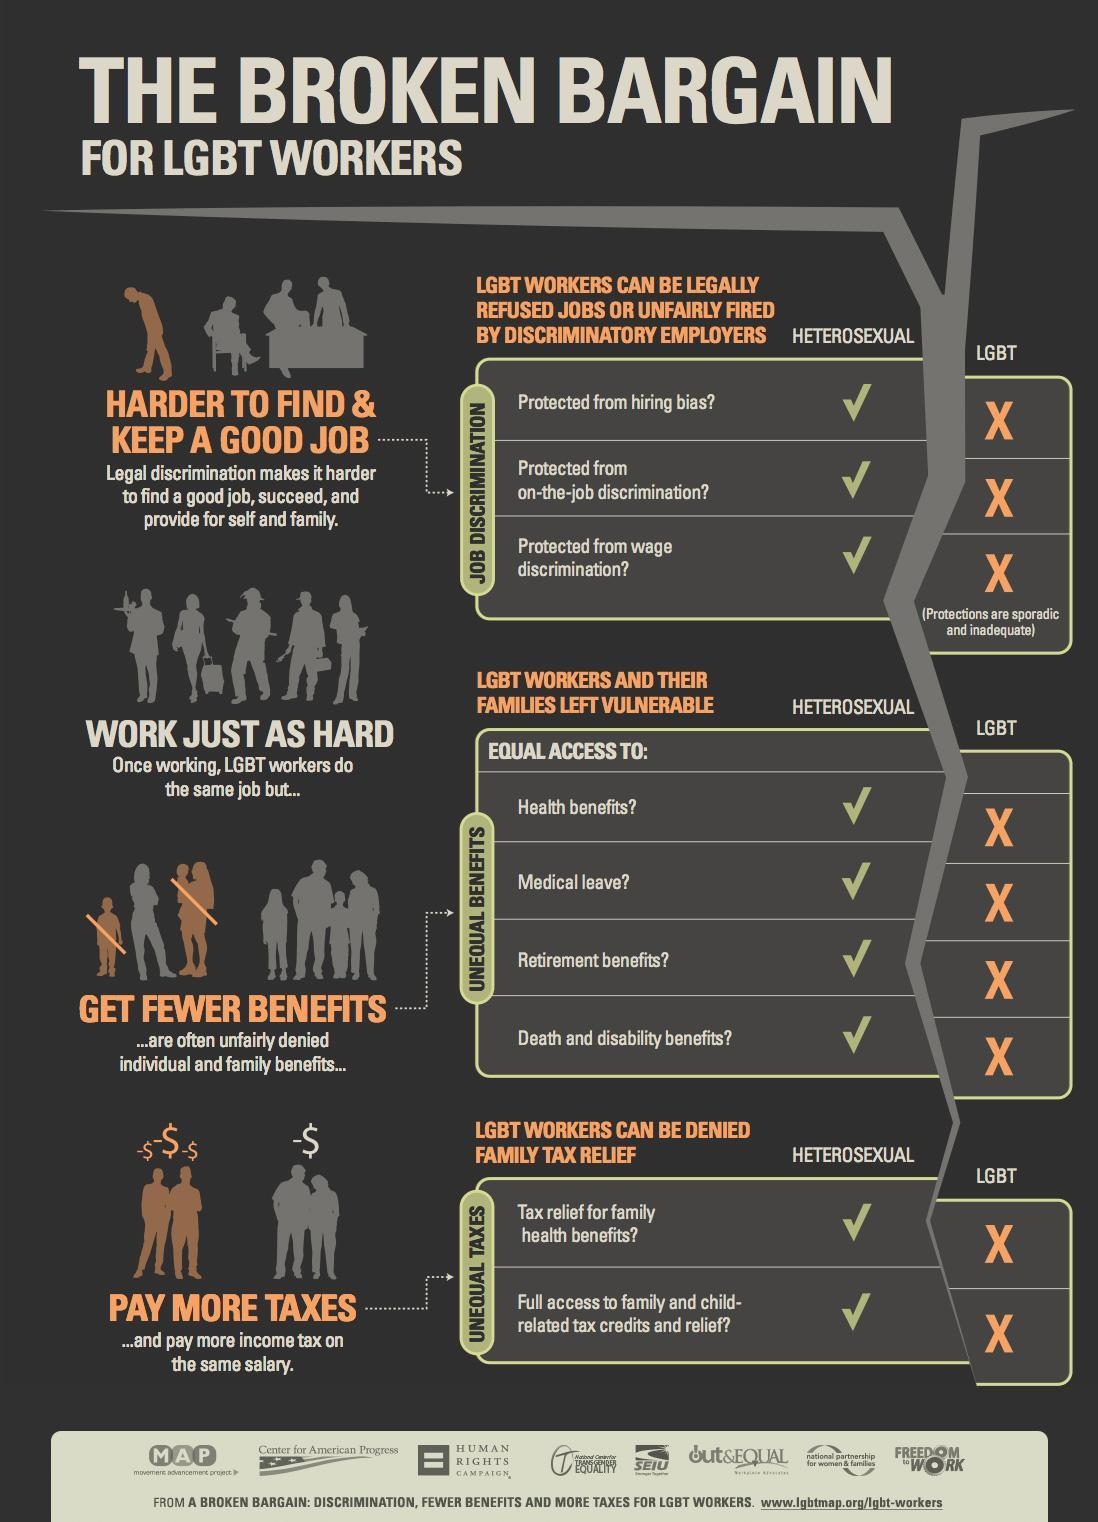Which workers have to pay more taxes?
Answer the question with a short phrase. LGBT What makes it difficult for LGBT people to get good jobs? Legal discrimination Which workers are denied health benefits? LGBT Which workers are not protected from wage discrimination? LGBT Which workers are protected from hiring bias? heterosexual 